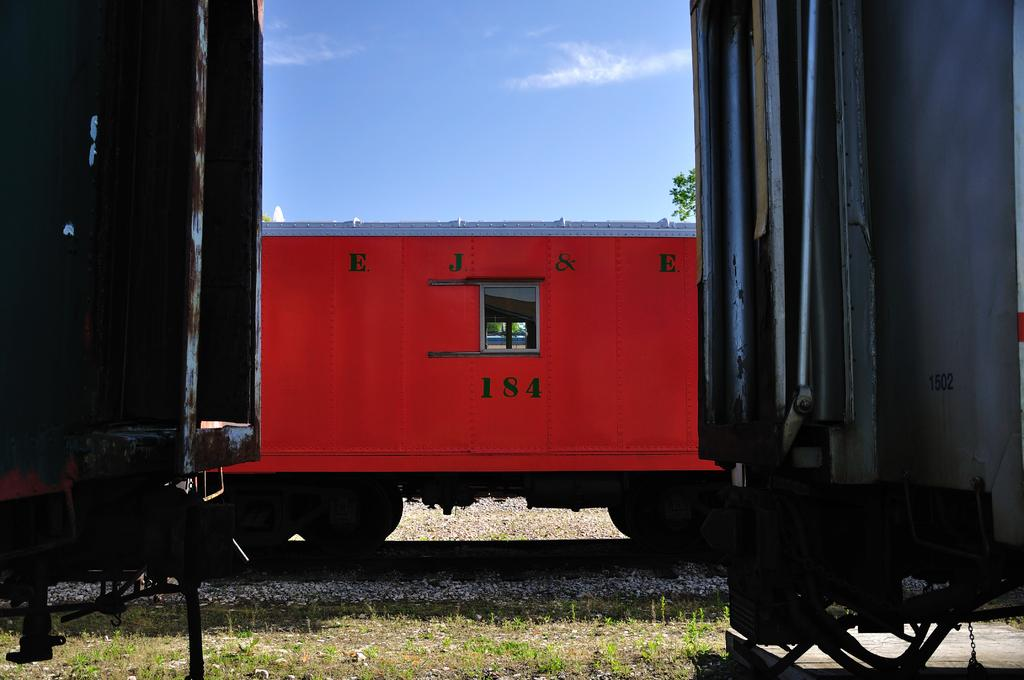What type of vehicles can be seen on the railway track in the image? There are trains on the railway track in the image. What type of vegetation is present on the ground in the image? There are plants and grass on the ground in the image. Can you describe the tree visible in the image? There is a tree visible in the image. What is visible at the top of the image? The sky is visible at the top of the image. Can you see any ants or tigers at the seashore in the image? There is no seashore present in the image, and therefore no ants or tigers can be seen. 